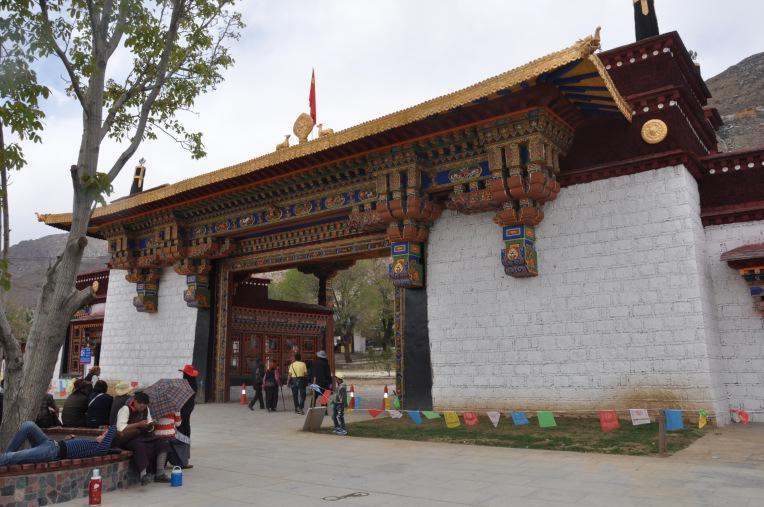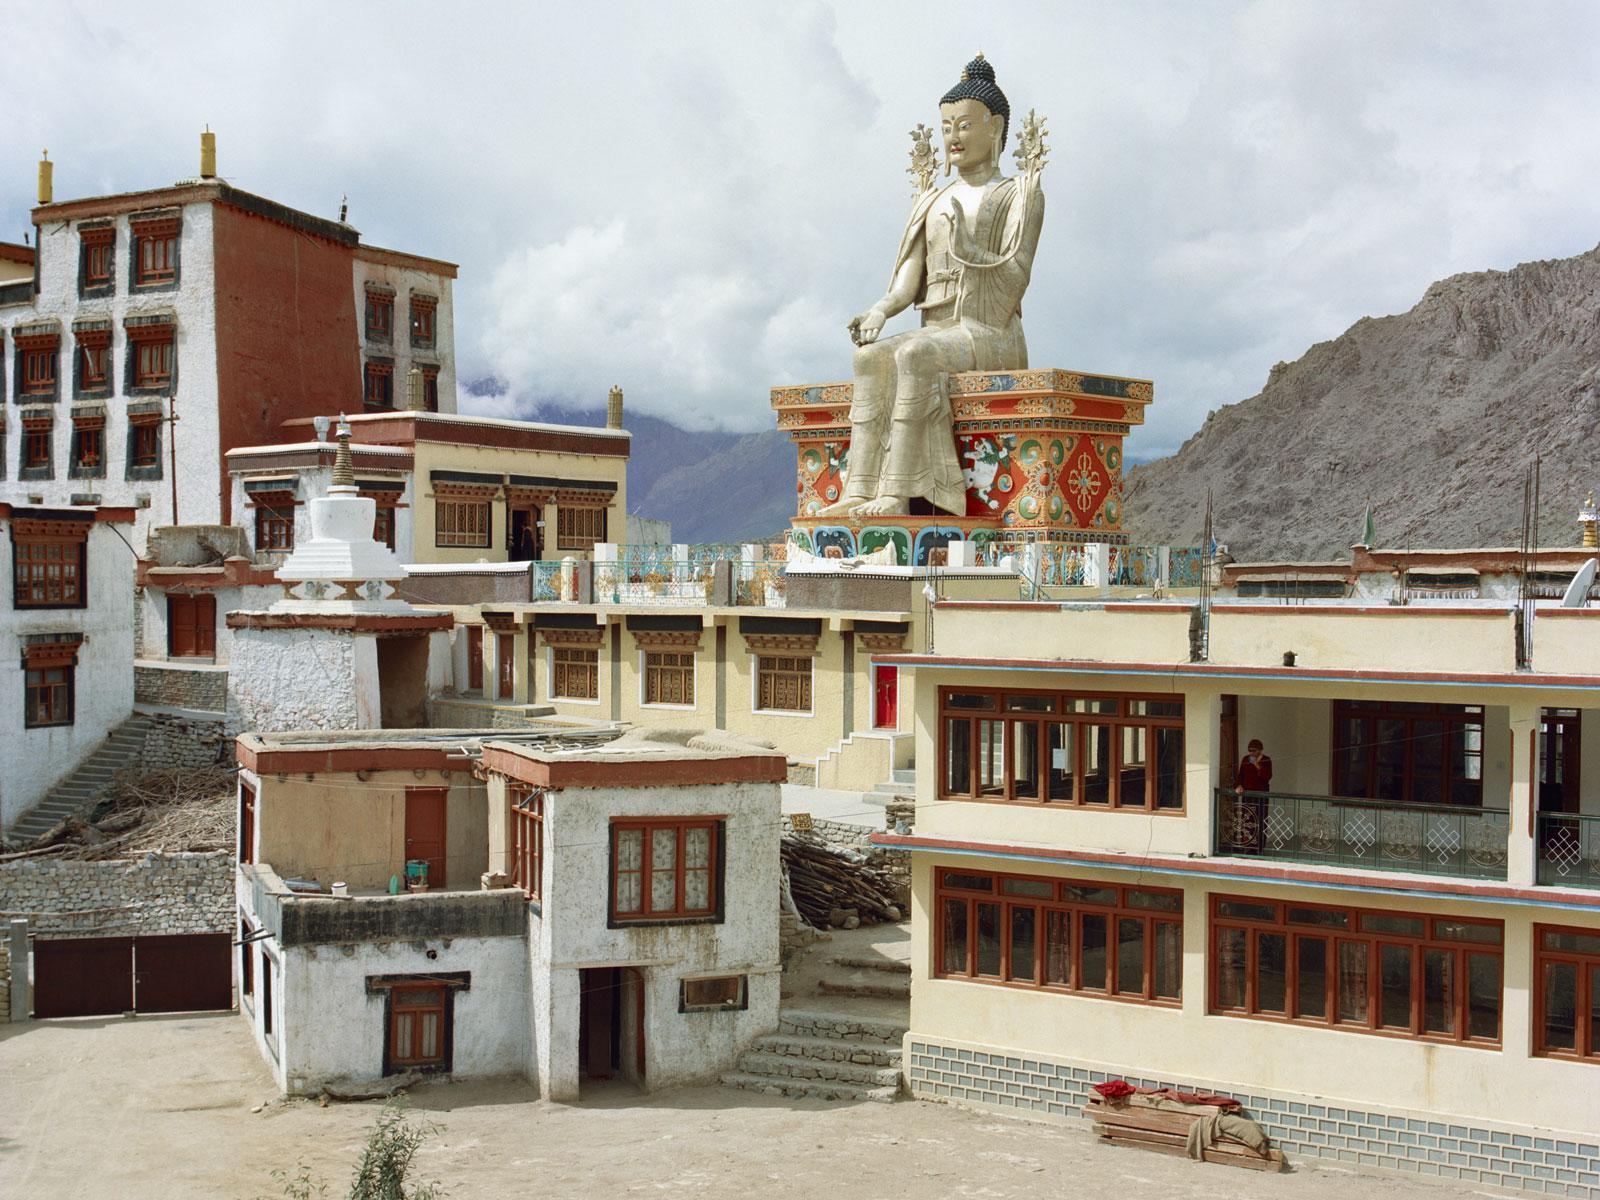The first image is the image on the left, the second image is the image on the right. For the images shown, is this caption "People walk the streets in an historic area." true? Answer yes or no. Yes. The first image is the image on the left, the second image is the image on the right. Evaluate the accuracy of this statement regarding the images: "Multiple domes topped with crosses are included in one image.". Is it true? Answer yes or no. No. 